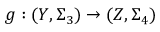<formula> <loc_0><loc_0><loc_500><loc_500>g \colon ( Y , \Sigma _ { 3 } ) \to ( Z , \Sigma _ { 4 } )</formula> 